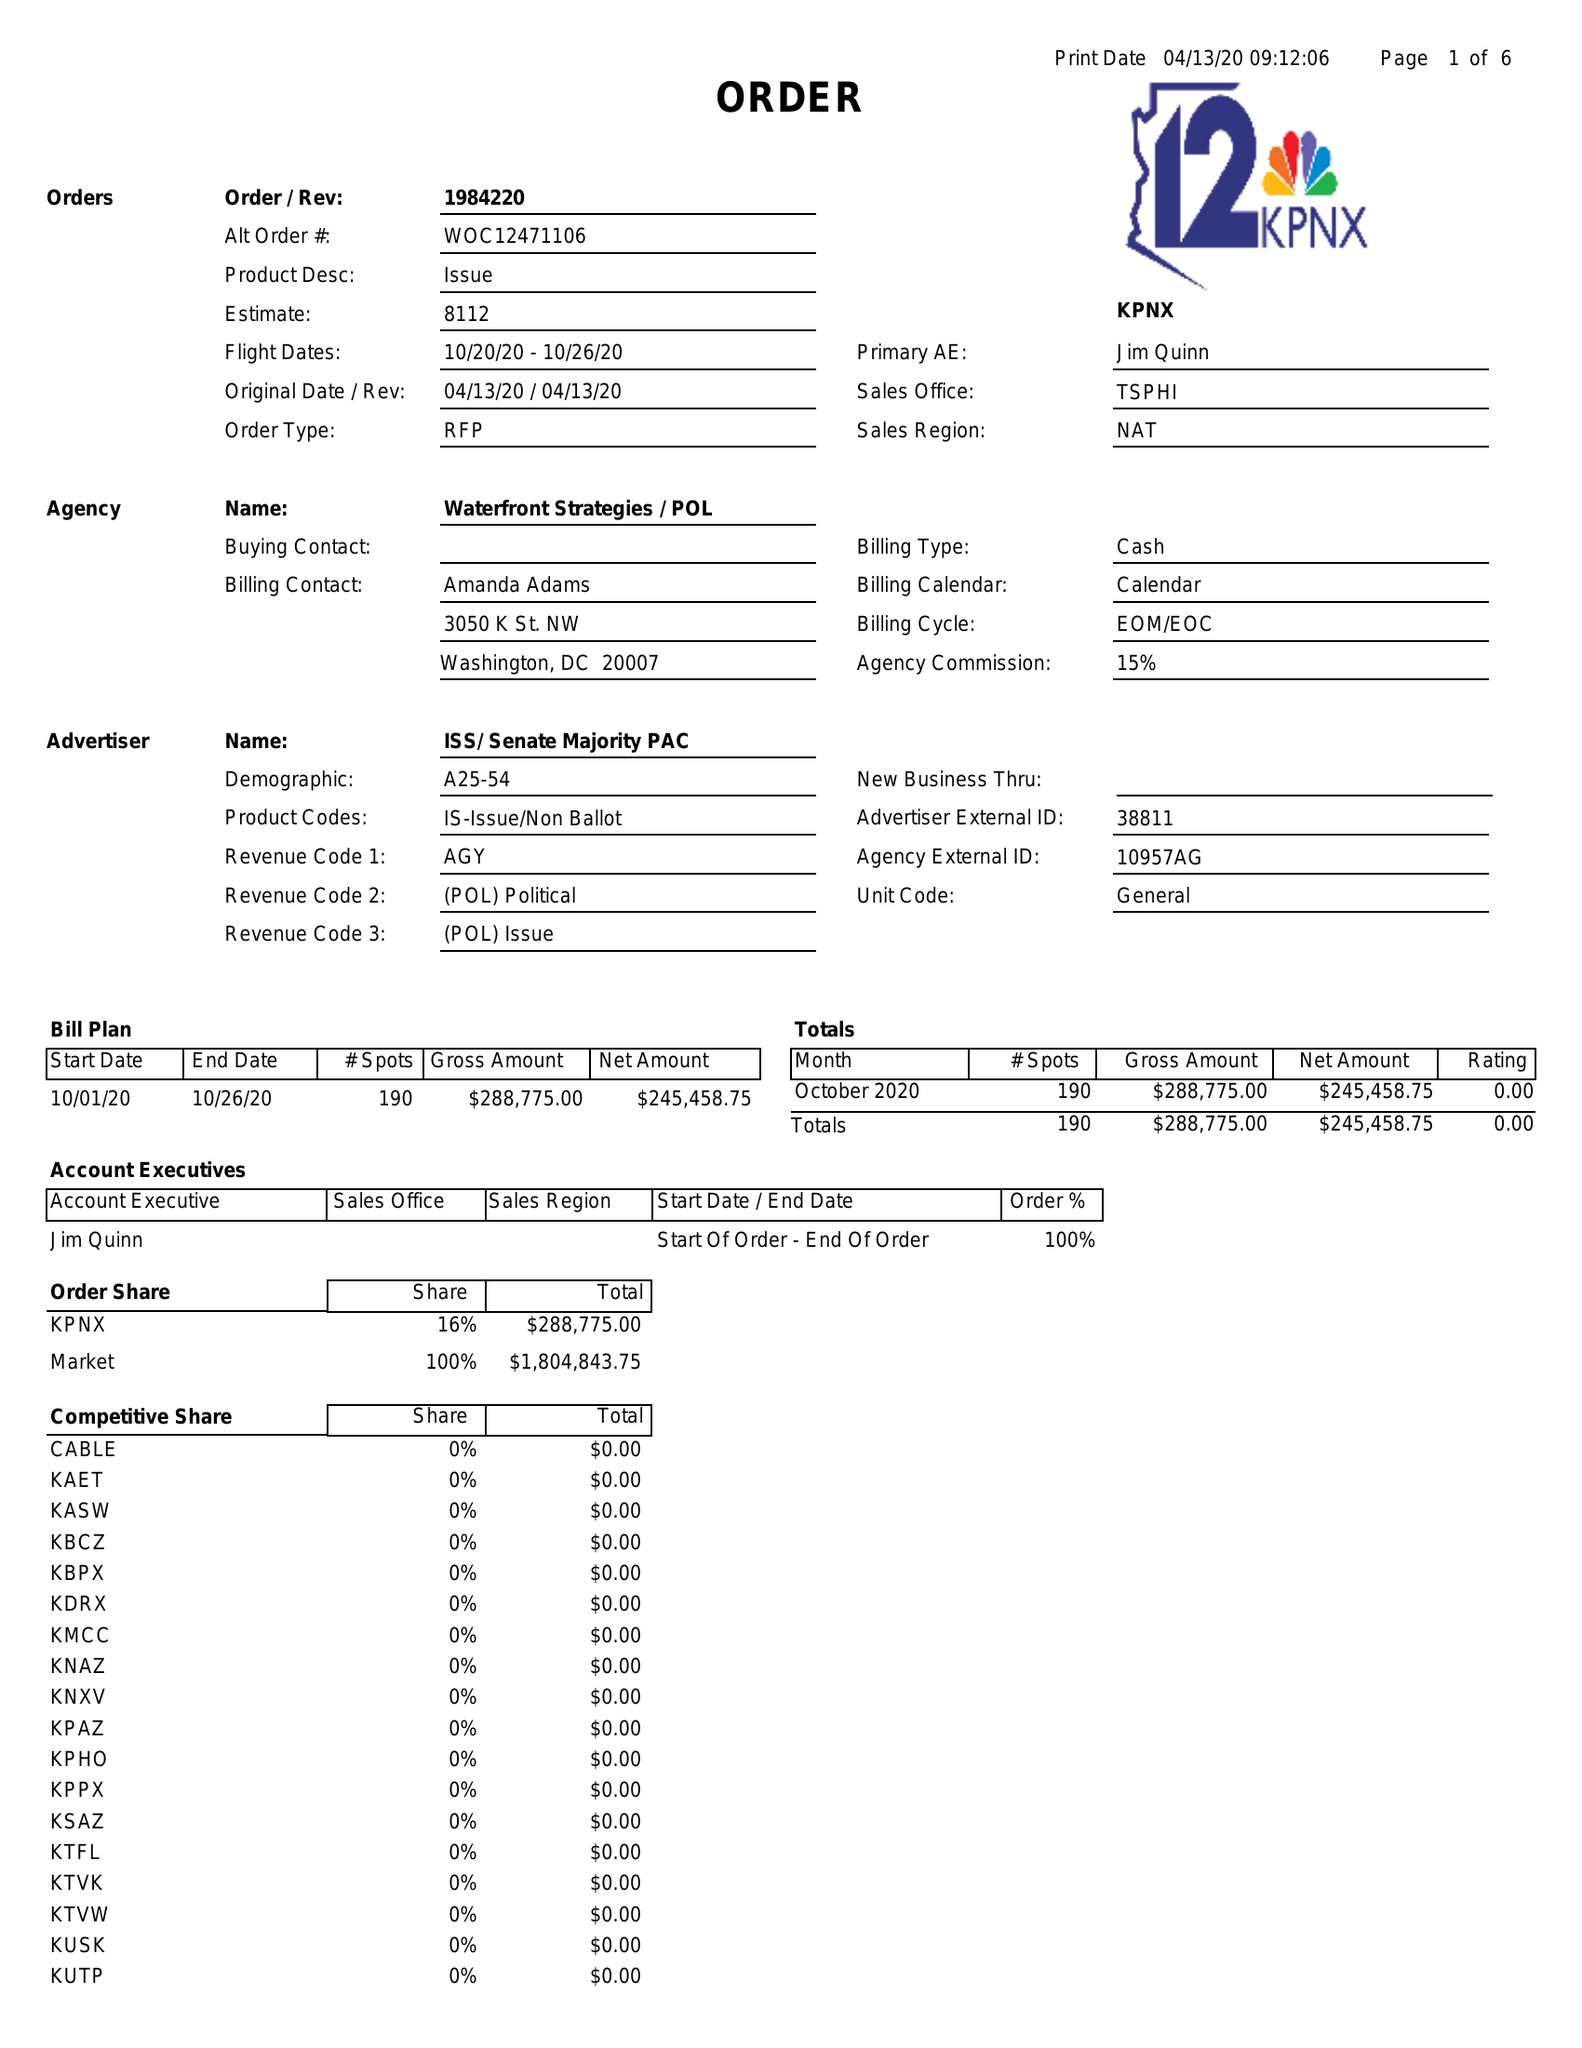What is the value for the gross_amount?
Answer the question using a single word or phrase. 288775.00 